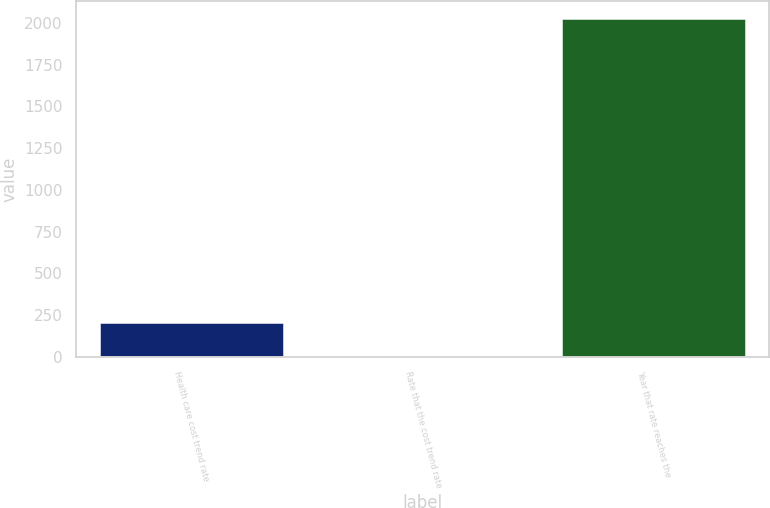<chart> <loc_0><loc_0><loc_500><loc_500><bar_chart><fcel>Health care cost trend rate<fcel>Rate that the cost trend rate<fcel>Year that rate reaches the<nl><fcel>207.3<fcel>5<fcel>2028<nl></chart> 